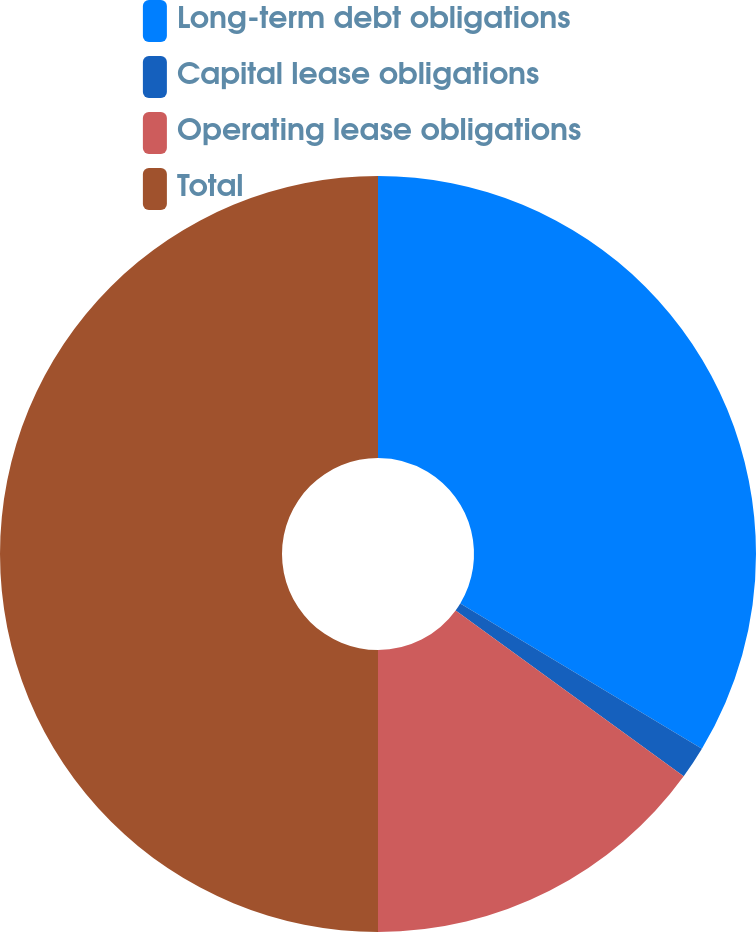<chart> <loc_0><loc_0><loc_500><loc_500><pie_chart><fcel>Long-term debt obligations<fcel>Capital lease obligations<fcel>Operating lease obligations<fcel>Total<nl><fcel>33.62%<fcel>1.39%<fcel>14.99%<fcel>50.0%<nl></chart> 